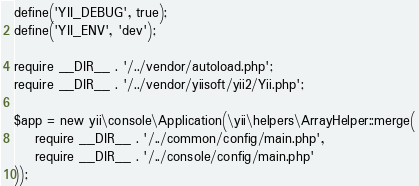Convert code to text. <code><loc_0><loc_0><loc_500><loc_500><_PHP_>
define('YII_DEBUG', true);
define('YII_ENV', 'dev');

require __DIR__ . '/../vendor/autoload.php';
require __DIR__ . '/../vendor/yiisoft/yii2/Yii.php';

$app = new yii\console\Application(\yii\helpers\ArrayHelper::merge(
    require __DIR__ . '/../common/config/main.php',
    require __DIR__ . '/../console/config/main.php'
));
</code> 